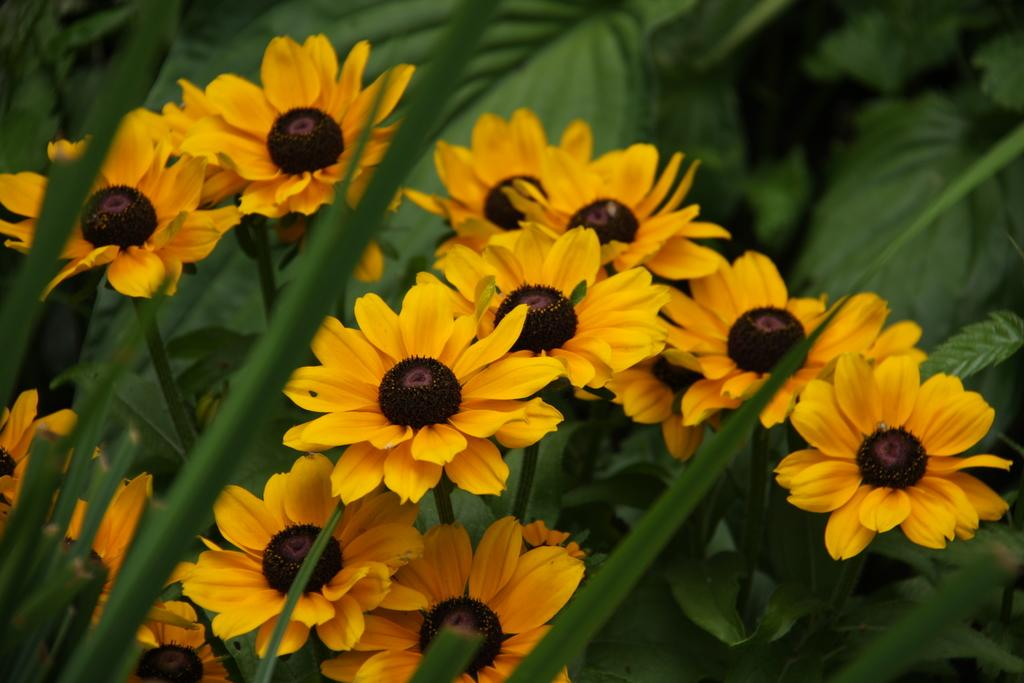What type of plants can be seen in the image? There is a group of flowers and trees in the image. Can you describe the setting in which the plants are located? The image features a natural setting with flowers and trees. What idea is being printed on the flowers in the image? There is no indication in the image that any ideas are being printed on the flowers. 